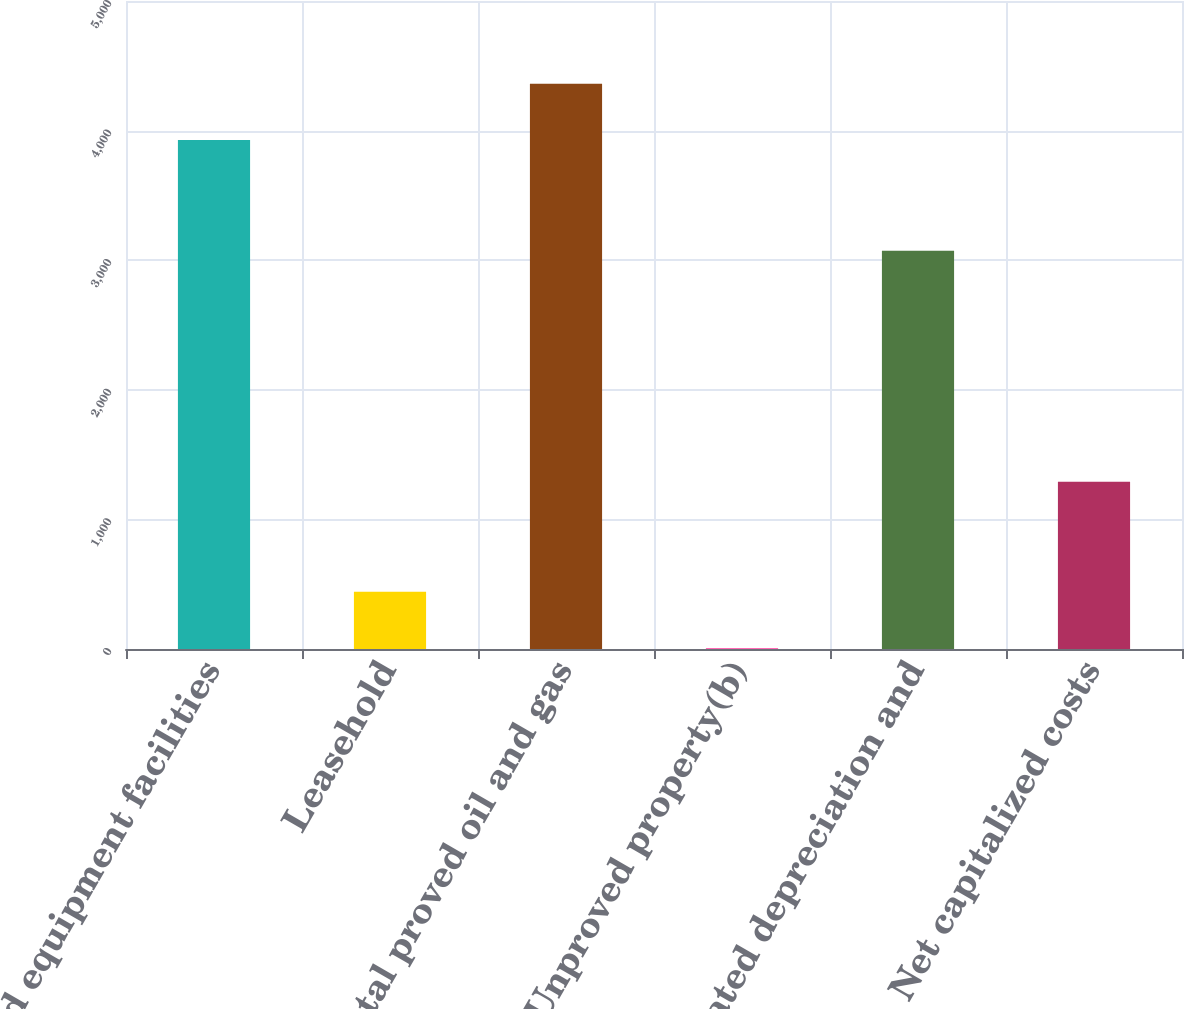<chart> <loc_0><loc_0><loc_500><loc_500><bar_chart><fcel>Wells and equipment facilities<fcel>Leasehold<fcel>Total proved oil and gas<fcel>Unproved property(b)<fcel>Accumulated depreciation and<fcel>Net capitalized costs<nl><fcel>3927<fcel>442.7<fcel>4361.7<fcel>8<fcel>3072<fcel>1291<nl></chart> 